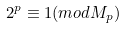Convert formula to latex. <formula><loc_0><loc_0><loc_500><loc_500>2 ^ { p } \equiv 1 ( m o d M _ { p } )</formula> 